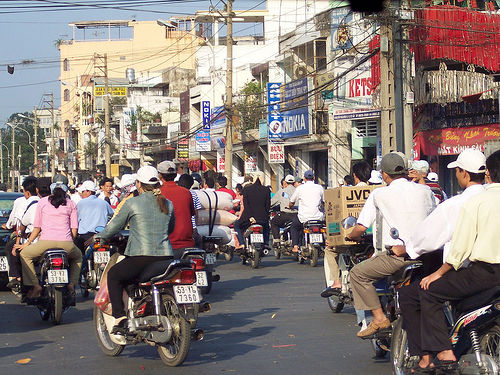<image>
Can you confirm if the woman is behind the man? Yes. From this viewpoint, the woman is positioned behind the man, with the man partially or fully occluding the woman. Where is the motorcycle in relation to the man? Is it on the man? No. The motorcycle is not positioned on the man. They may be near each other, but the motorcycle is not supported by or resting on top of the man. 